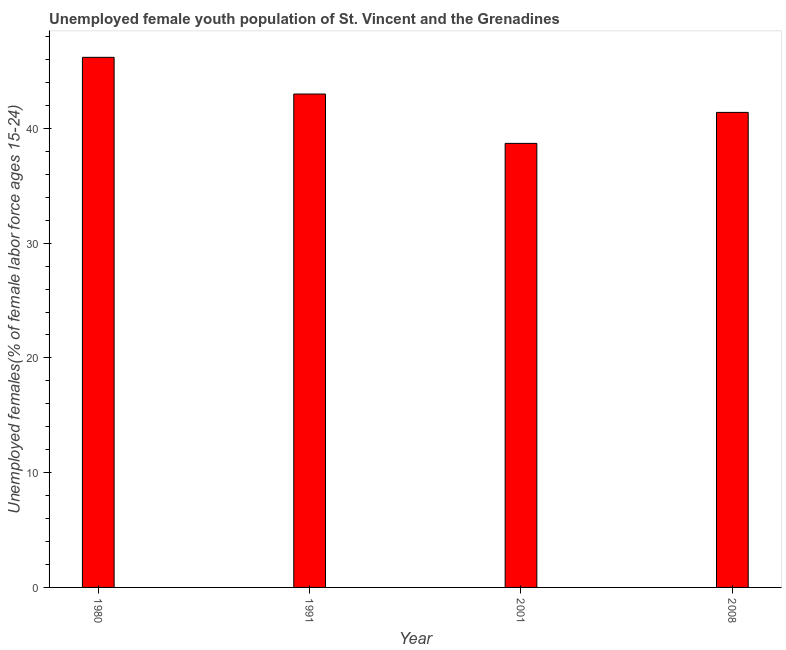Does the graph contain any zero values?
Provide a succinct answer. No. Does the graph contain grids?
Make the answer very short. No. What is the title of the graph?
Give a very brief answer. Unemployed female youth population of St. Vincent and the Grenadines. What is the label or title of the X-axis?
Make the answer very short. Year. What is the label or title of the Y-axis?
Provide a short and direct response. Unemployed females(% of female labor force ages 15-24). What is the unemployed female youth in 1980?
Your answer should be very brief. 46.2. Across all years, what is the maximum unemployed female youth?
Provide a succinct answer. 46.2. Across all years, what is the minimum unemployed female youth?
Ensure brevity in your answer.  38.7. In which year was the unemployed female youth minimum?
Your answer should be very brief. 2001. What is the sum of the unemployed female youth?
Offer a very short reply. 169.3. What is the average unemployed female youth per year?
Make the answer very short. 42.33. What is the median unemployed female youth?
Your answer should be very brief. 42.2. In how many years, is the unemployed female youth greater than 22 %?
Give a very brief answer. 4. What is the ratio of the unemployed female youth in 1980 to that in 2008?
Provide a short and direct response. 1.12. Is the unemployed female youth in 1991 less than that in 2001?
Your answer should be very brief. No. What is the difference between the highest and the second highest unemployed female youth?
Provide a short and direct response. 3.2. In how many years, is the unemployed female youth greater than the average unemployed female youth taken over all years?
Ensure brevity in your answer.  2. Are all the bars in the graph horizontal?
Your answer should be very brief. No. What is the Unemployed females(% of female labor force ages 15-24) of 1980?
Keep it short and to the point. 46.2. What is the Unemployed females(% of female labor force ages 15-24) in 1991?
Offer a terse response. 43. What is the Unemployed females(% of female labor force ages 15-24) in 2001?
Provide a succinct answer. 38.7. What is the Unemployed females(% of female labor force ages 15-24) of 2008?
Provide a succinct answer. 41.4. What is the difference between the Unemployed females(% of female labor force ages 15-24) in 1980 and 1991?
Your answer should be compact. 3.2. What is the difference between the Unemployed females(% of female labor force ages 15-24) in 1980 and 2001?
Provide a short and direct response. 7.5. What is the ratio of the Unemployed females(% of female labor force ages 15-24) in 1980 to that in 1991?
Make the answer very short. 1.07. What is the ratio of the Unemployed females(% of female labor force ages 15-24) in 1980 to that in 2001?
Offer a terse response. 1.19. What is the ratio of the Unemployed females(% of female labor force ages 15-24) in 1980 to that in 2008?
Provide a succinct answer. 1.12. What is the ratio of the Unemployed females(% of female labor force ages 15-24) in 1991 to that in 2001?
Your answer should be compact. 1.11. What is the ratio of the Unemployed females(% of female labor force ages 15-24) in 1991 to that in 2008?
Your answer should be very brief. 1.04. What is the ratio of the Unemployed females(% of female labor force ages 15-24) in 2001 to that in 2008?
Your response must be concise. 0.94. 